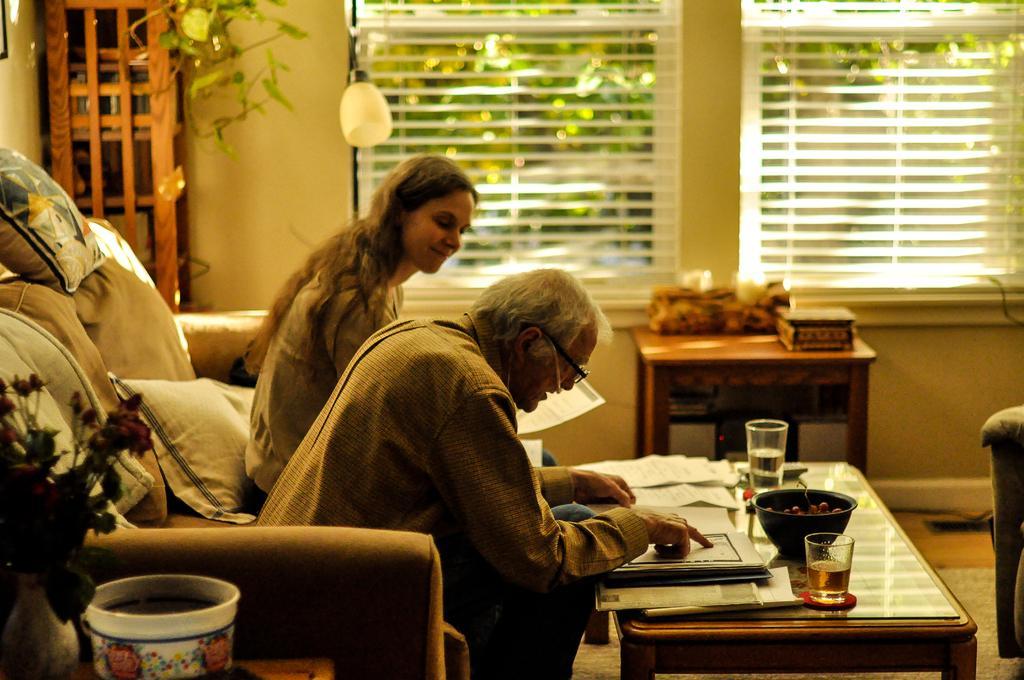Could you give a brief overview of what you see in this image? This is the picture in a house, there are two people siting in a couch this man who is reading in a book and this is women who is looking into the book. This is a table on the table there are two glass in one glass there is a wine and the other glass there is a water there is a bowl which is in black color on the bowl with fruits, on the couch there are the pillows background of this two people there is a wall and window on the window we can see the trees and there is lamp which is in white color and this are the shelf's and there is other table on the top of the table there is a box. 